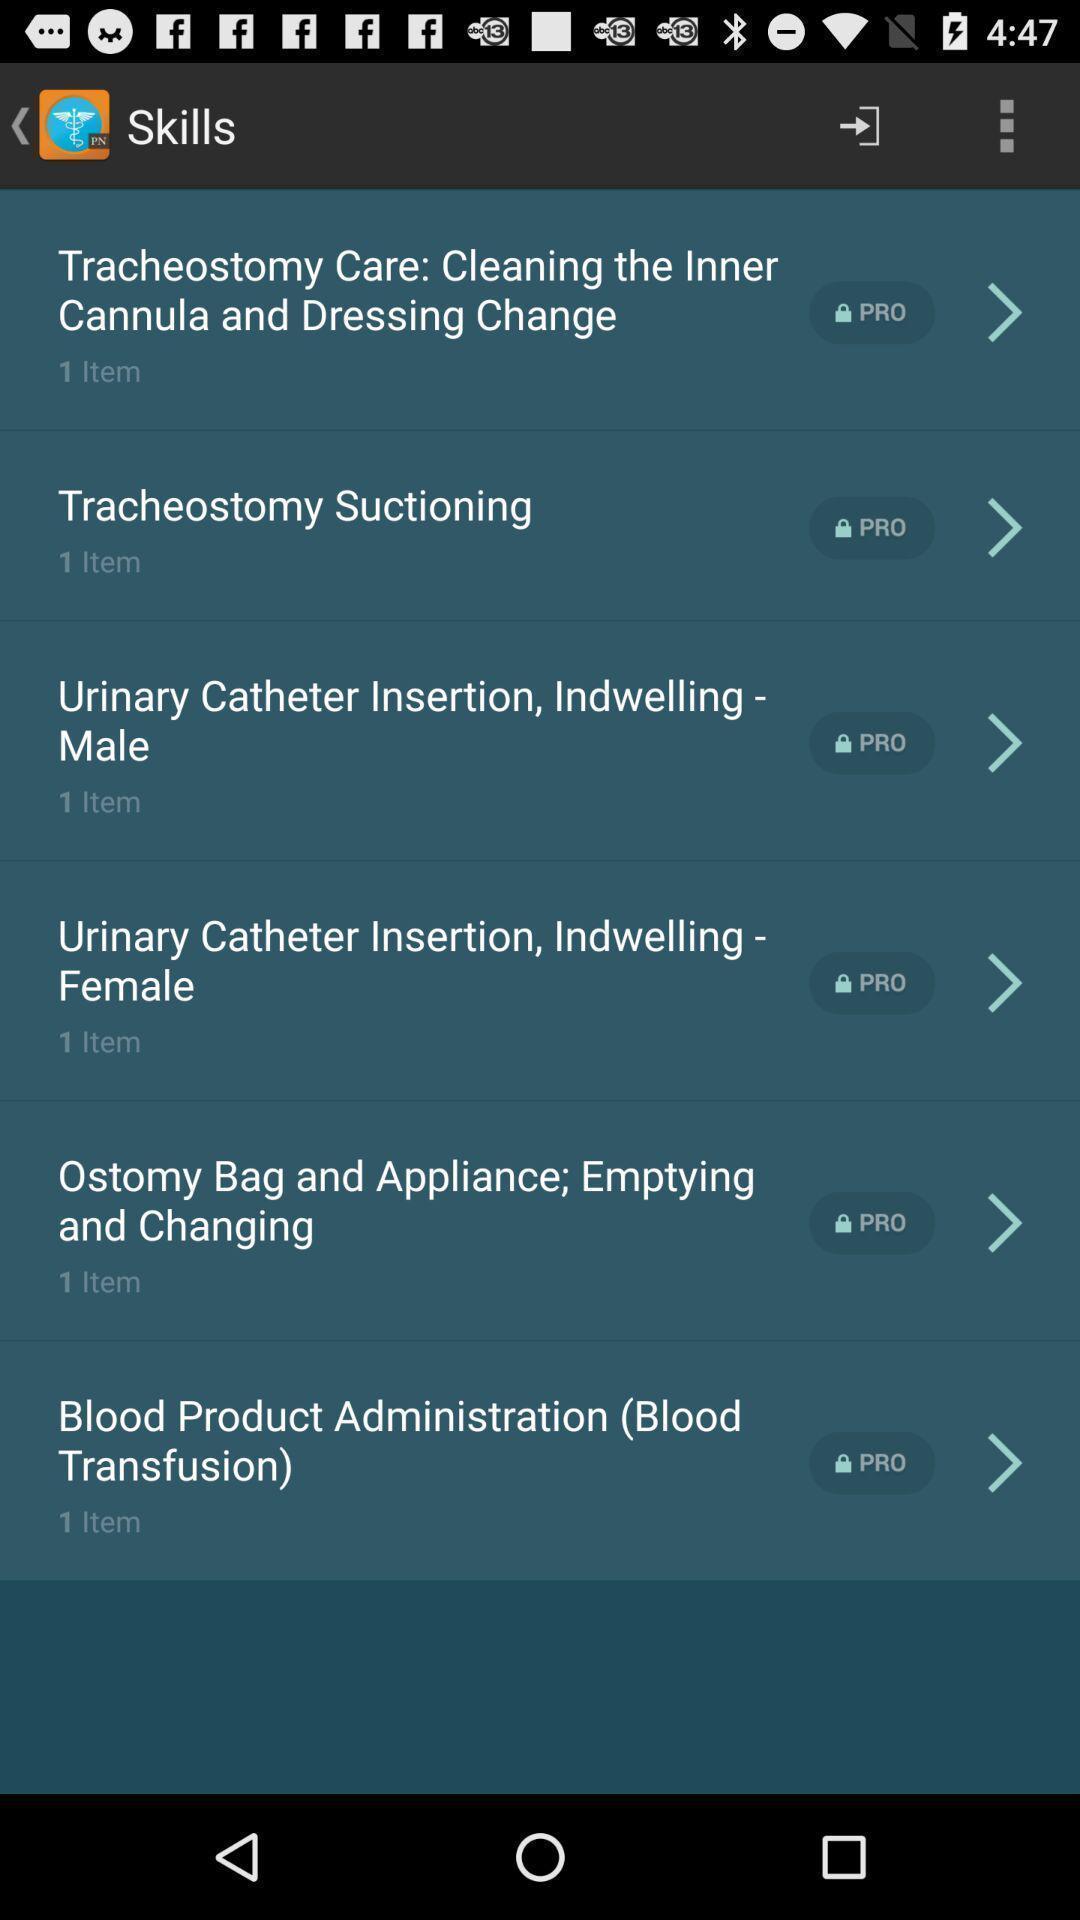Describe this image in words. Page showing different skills on a learning app. 